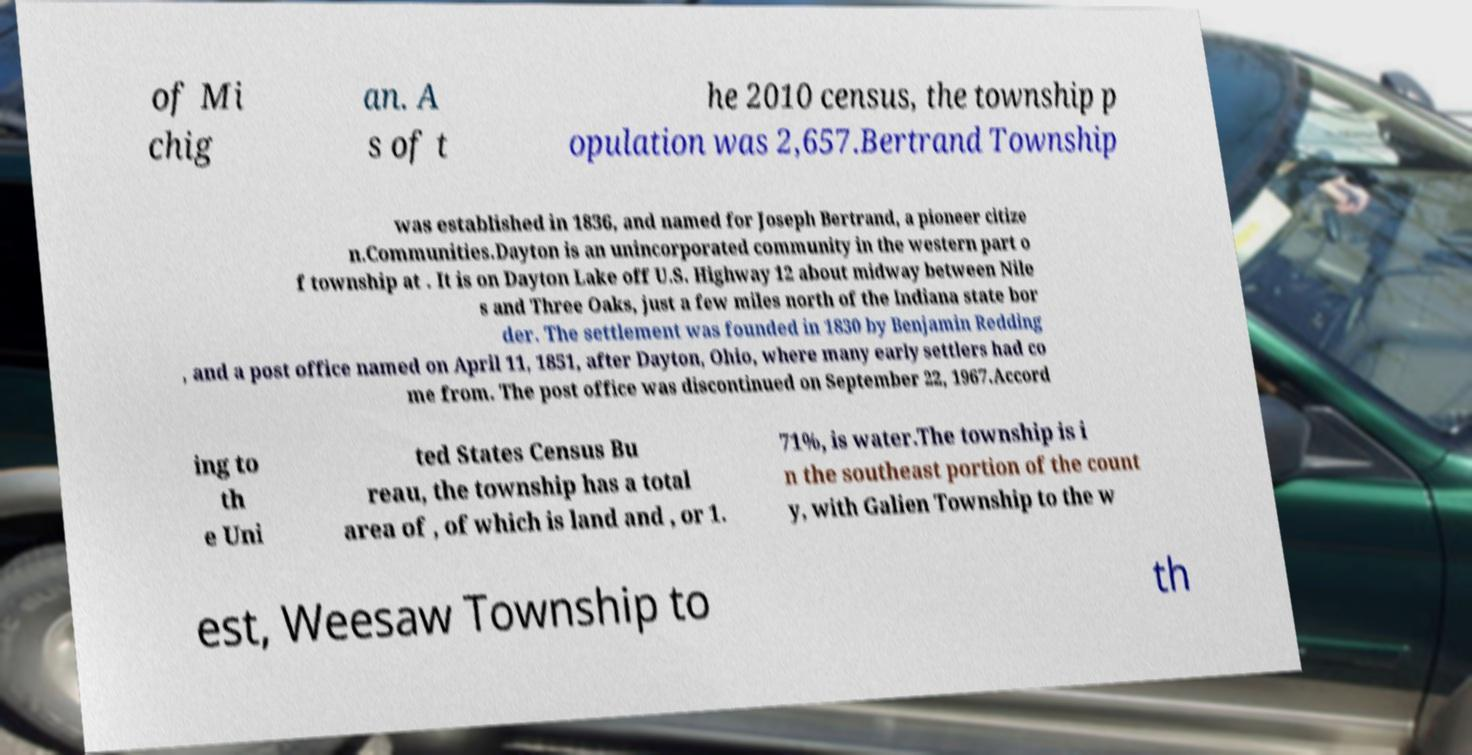Could you assist in decoding the text presented in this image and type it out clearly? of Mi chig an. A s of t he 2010 census, the township p opulation was 2,657.Bertrand Township was established in 1836, and named for Joseph Bertrand, a pioneer citize n.Communities.Dayton is an unincorporated community in the western part o f township at . It is on Dayton Lake off U.S. Highway 12 about midway between Nile s and Three Oaks, just a few miles north of the Indiana state bor der. The settlement was founded in 1830 by Benjamin Redding , and a post office named on April 11, 1851, after Dayton, Ohio, where many early settlers had co me from. The post office was discontinued on September 22, 1967.Accord ing to th e Uni ted States Census Bu reau, the township has a total area of , of which is land and , or 1. 71%, is water.The township is i n the southeast portion of the count y, with Galien Township to the w est, Weesaw Township to th 